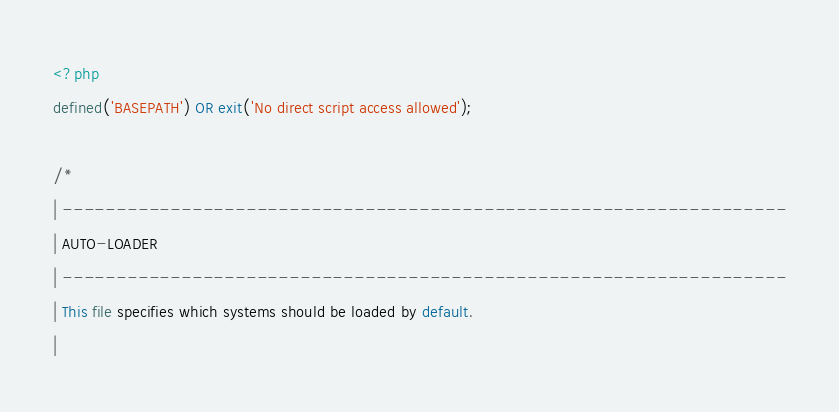Convert code to text. <code><loc_0><loc_0><loc_500><loc_500><_PHP_><?php
defined('BASEPATH') OR exit('No direct script access allowed');

/*
| -------------------------------------------------------------------
| AUTO-LOADER
| -------------------------------------------------------------------
| This file specifies which systems should be loaded by default.
|</code> 